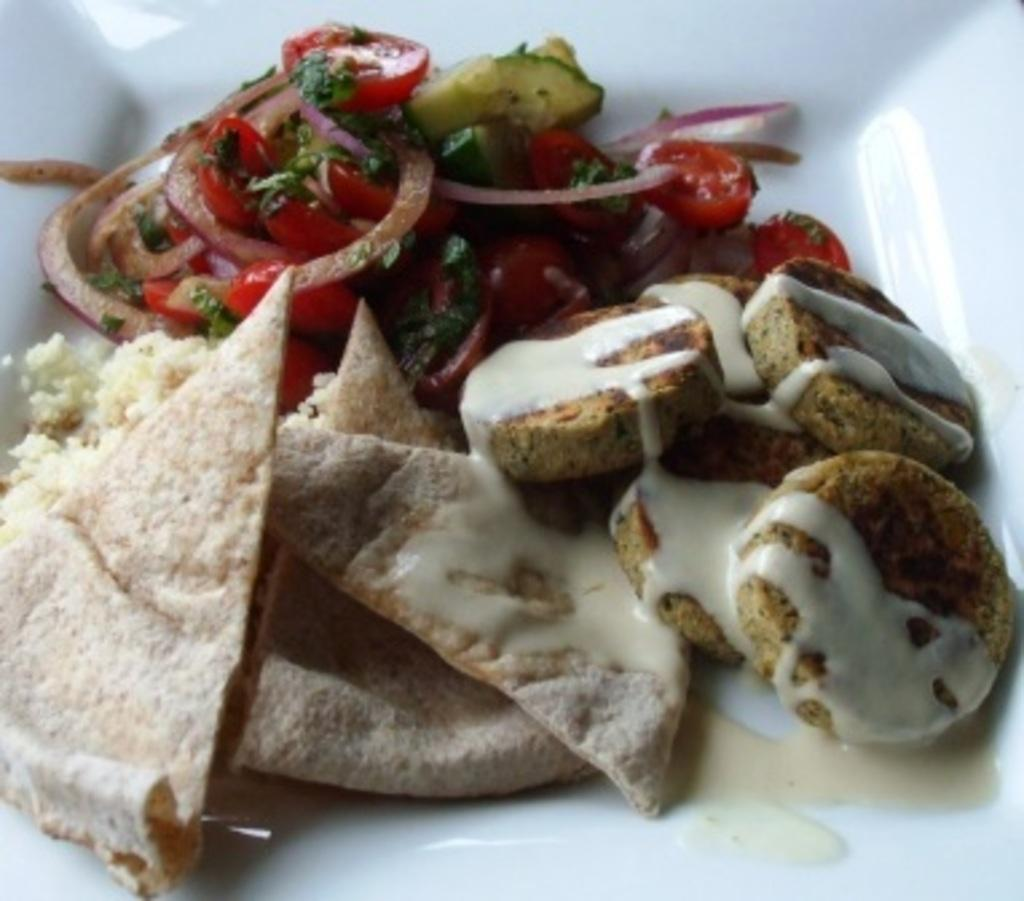What is the main subject of the image? There is a food item in the image. How is the food item presented in the image? The food item is in a white-colored bowl. Where is the bowl located in the image? The bowl is in the middle of the image. What type of bone can be seen in the image? There is no bone present in the image; it features a food item in a white-colored bowl. 